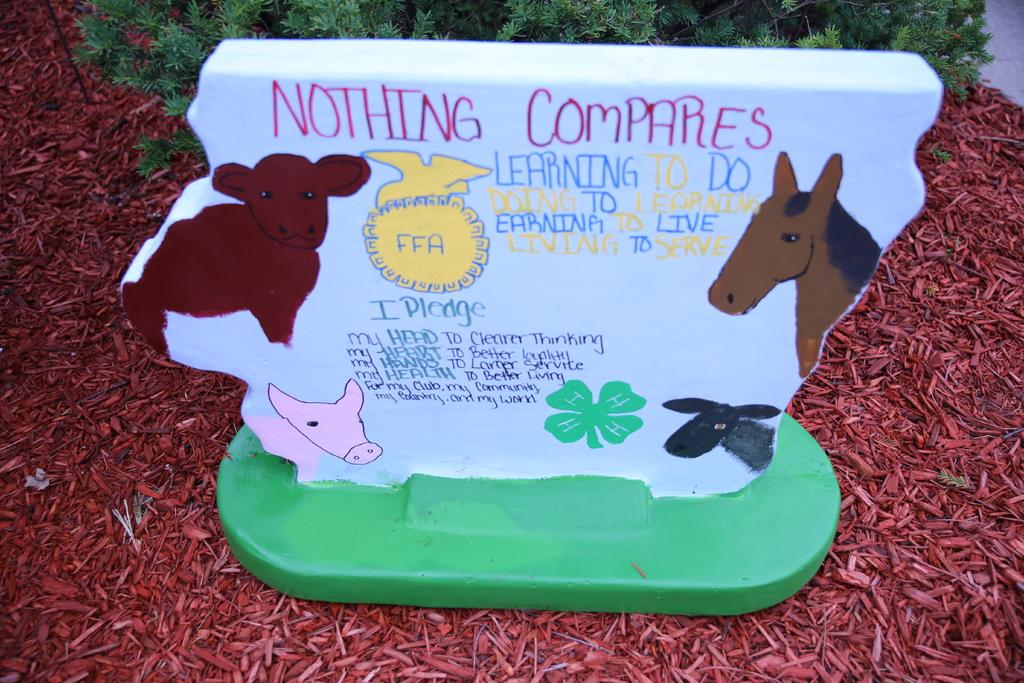What is the main subject of the image? There is a white object in the image. What can be seen on the white object? The white object has images of animals on it and text. Where is the white object located in the image? The white object is placed on the ground. What can be seen in the background of the image? There are plants in the background of the image. What type of rail can be seen connecting the animals on the white object? There is no rail present on the white object or in the image. How does the sponge contribute to the process depicted in the image? There is no sponge or process depicted in the image; it only features a white object with animal images and text. 